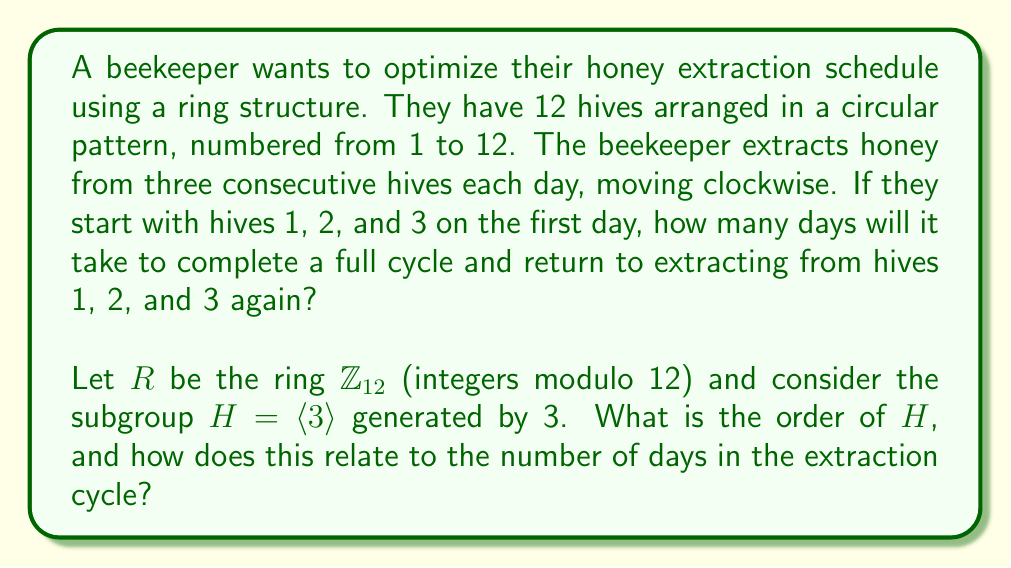Help me with this question. To solve this problem, we need to understand the structure of the ring $\mathbb{Z}_{12}$ and the subgroup generated by 3.

1) First, let's consider the subgroup $H = \langle 3 \rangle$ in $\mathbb{Z}_{12}$:
   
   $H = \{3, 6, 9, 0\}$

   This is because:
   $3 \cdot 1 = 3$
   $3 \cdot 2 = 6$
   $3 \cdot 3 = 9$
   $3 \cdot 4 = 12 \equiv 0 \pmod{12}$

2) The order of $H$ is 4, as there are 4 elements in the subgroup.

3) Now, let's consider how this relates to the extraction schedule:
   - Day 1: Hives 1, 2, 3
   - Day 2: Hives 4, 5, 6
   - Day 3: Hives 7, 8, 9
   - Day 4: Hives 10, 11, 12
   - Day 5: Back to hives 1, 2, 3

4) We can see that the starting hive of each day follows the pattern of the subgroup $H$:
   Day 1 starts at hive 1
   Day 2 starts at hive 4 (1 + 3)
   Day 3 starts at hive 7 (4 + 3)
   Day 4 starts at hive 10 (7 + 3)
   Day 5 starts at hive 1 again (10 + 3 ≡ 1 mod 12)

5) The number of days in the cycle is equal to the order of the subgroup $H$, which is 4.

This ring structure optimizes the extraction schedule by ensuring that all hives are visited regularly and in a systematic order, completing a full cycle every 4 days.
Answer: The order of the subgroup $H = \langle 3 \rangle$ in $\mathbb{Z}_{12}$ is 4, which corresponds to the number of days it takes to complete a full honey extraction cycle. 